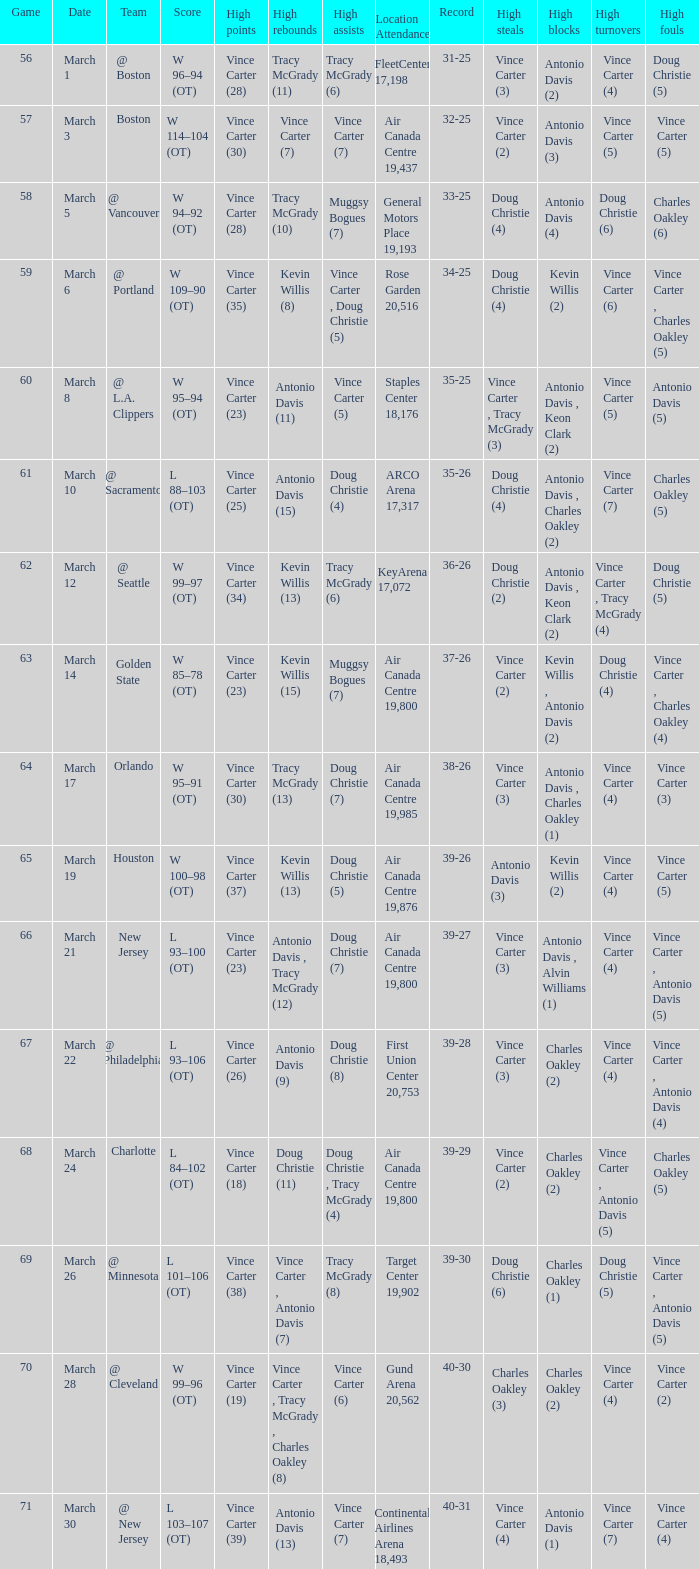Where did the team play and what was the attendance against new jersey? Air Canada Centre 19,800. 